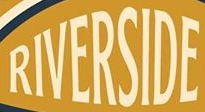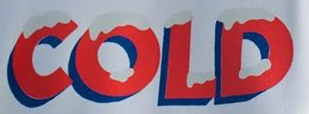What words are shown in these images in order, separated by a semicolon? RIVERSIDE; COLD 